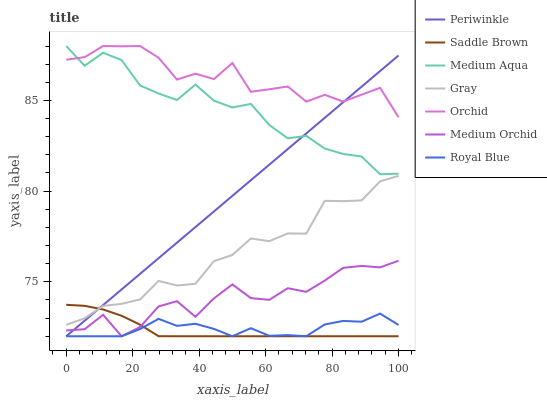Does Saddle Brown have the minimum area under the curve?
Answer yes or no. Yes. Does Orchid have the maximum area under the curve?
Answer yes or no. Yes. Does Medium Orchid have the minimum area under the curve?
Answer yes or no. No. Does Medium Orchid have the maximum area under the curve?
Answer yes or no. No. Is Periwinkle the smoothest?
Answer yes or no. Yes. Is Orchid the roughest?
Answer yes or no. Yes. Is Medium Orchid the smoothest?
Answer yes or no. No. Is Medium Orchid the roughest?
Answer yes or no. No. Does Medium Orchid have the lowest value?
Answer yes or no. Yes. Does Medium Aqua have the lowest value?
Answer yes or no. No. Does Orchid have the highest value?
Answer yes or no. Yes. Does Medium Orchid have the highest value?
Answer yes or no. No. Is Royal Blue less than Orchid?
Answer yes or no. Yes. Is Orchid greater than Royal Blue?
Answer yes or no. Yes. Does Periwinkle intersect Medium Orchid?
Answer yes or no. Yes. Is Periwinkle less than Medium Orchid?
Answer yes or no. No. Is Periwinkle greater than Medium Orchid?
Answer yes or no. No. Does Royal Blue intersect Orchid?
Answer yes or no. No. 